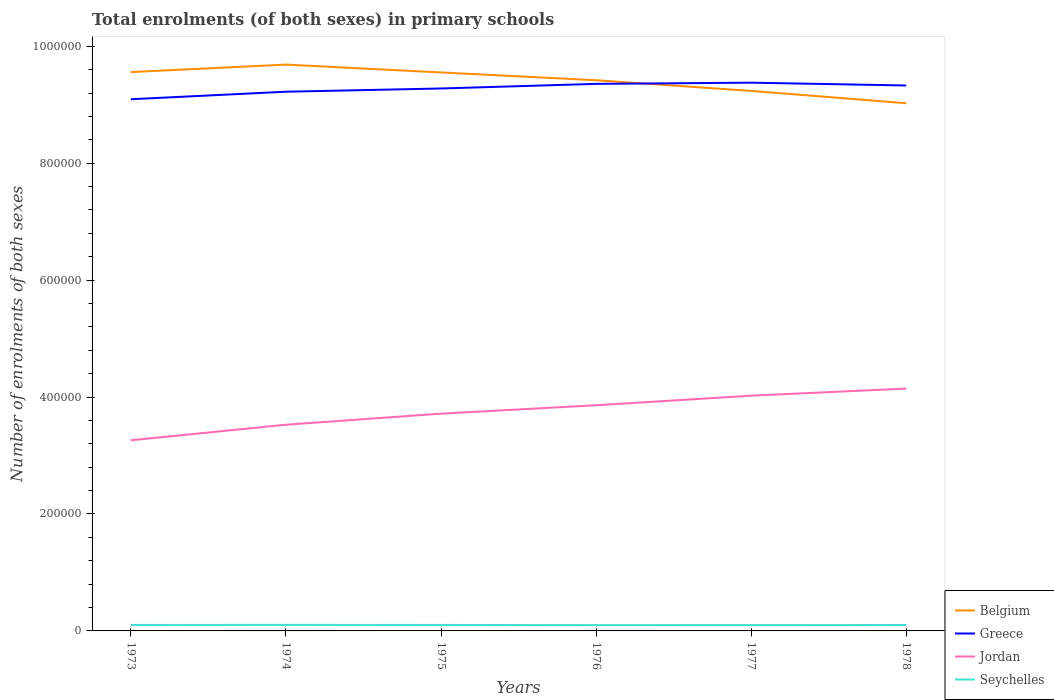Is the number of lines equal to the number of legend labels?
Give a very brief answer. Yes. Across all years, what is the maximum number of enrolments in primary schools in Belgium?
Provide a succinct answer. 9.03e+05. In which year was the number of enrolments in primary schools in Belgium maximum?
Make the answer very short. 1978. What is the total number of enrolments in primary schools in Belgium in the graph?
Your answer should be compact. 2.67e+04. What is the difference between the highest and the second highest number of enrolments in primary schools in Jordan?
Give a very brief answer. 8.84e+04. How many lines are there?
Give a very brief answer. 4. How many years are there in the graph?
Offer a terse response. 6. Are the values on the major ticks of Y-axis written in scientific E-notation?
Your response must be concise. No. Where does the legend appear in the graph?
Your response must be concise. Bottom right. How many legend labels are there?
Give a very brief answer. 4. How are the legend labels stacked?
Offer a terse response. Vertical. What is the title of the graph?
Offer a very short reply. Total enrolments (of both sexes) in primary schools. Does "Congo (Democratic)" appear as one of the legend labels in the graph?
Offer a terse response. No. What is the label or title of the X-axis?
Provide a short and direct response. Years. What is the label or title of the Y-axis?
Your answer should be compact. Number of enrolments of both sexes. What is the Number of enrolments of both sexes of Belgium in 1973?
Give a very brief answer. 9.56e+05. What is the Number of enrolments of both sexes of Greece in 1973?
Provide a short and direct response. 9.09e+05. What is the Number of enrolments of both sexes in Jordan in 1973?
Offer a terse response. 3.26e+05. What is the Number of enrolments of both sexes of Seychelles in 1973?
Provide a short and direct response. 1.03e+04. What is the Number of enrolments of both sexes of Belgium in 1974?
Offer a very short reply. 9.69e+05. What is the Number of enrolments of both sexes of Greece in 1974?
Give a very brief answer. 9.22e+05. What is the Number of enrolments of both sexes in Jordan in 1974?
Make the answer very short. 3.53e+05. What is the Number of enrolments of both sexes of Seychelles in 1974?
Your response must be concise. 1.04e+04. What is the Number of enrolments of both sexes in Belgium in 1975?
Your answer should be compact. 9.55e+05. What is the Number of enrolments of both sexes of Greece in 1975?
Offer a very short reply. 9.28e+05. What is the Number of enrolments of both sexes of Jordan in 1975?
Your answer should be very brief. 3.72e+05. What is the Number of enrolments of both sexes of Seychelles in 1975?
Your answer should be very brief. 1.02e+04. What is the Number of enrolments of both sexes in Belgium in 1976?
Offer a very short reply. 9.42e+05. What is the Number of enrolments of both sexes of Greece in 1976?
Ensure brevity in your answer.  9.36e+05. What is the Number of enrolments of both sexes in Jordan in 1976?
Your response must be concise. 3.86e+05. What is the Number of enrolments of both sexes of Seychelles in 1976?
Offer a very short reply. 9950. What is the Number of enrolments of both sexes in Belgium in 1977?
Ensure brevity in your answer.  9.24e+05. What is the Number of enrolments of both sexes in Greece in 1977?
Keep it short and to the point. 9.38e+05. What is the Number of enrolments of both sexes in Jordan in 1977?
Offer a very short reply. 4.02e+05. What is the Number of enrolments of both sexes in Seychelles in 1977?
Your answer should be compact. 1.00e+04. What is the Number of enrolments of both sexes in Belgium in 1978?
Ensure brevity in your answer.  9.03e+05. What is the Number of enrolments of both sexes in Greece in 1978?
Your response must be concise. 9.33e+05. What is the Number of enrolments of both sexes of Jordan in 1978?
Ensure brevity in your answer.  4.14e+05. What is the Number of enrolments of both sexes of Seychelles in 1978?
Your answer should be very brief. 1.01e+04. Across all years, what is the maximum Number of enrolments of both sexes in Belgium?
Your answer should be compact. 9.69e+05. Across all years, what is the maximum Number of enrolments of both sexes of Greece?
Your answer should be very brief. 9.38e+05. Across all years, what is the maximum Number of enrolments of both sexes of Jordan?
Your answer should be compact. 4.14e+05. Across all years, what is the maximum Number of enrolments of both sexes in Seychelles?
Ensure brevity in your answer.  1.04e+04. Across all years, what is the minimum Number of enrolments of both sexes in Belgium?
Keep it short and to the point. 9.03e+05. Across all years, what is the minimum Number of enrolments of both sexes in Greece?
Your response must be concise. 9.09e+05. Across all years, what is the minimum Number of enrolments of both sexes in Jordan?
Your response must be concise. 3.26e+05. Across all years, what is the minimum Number of enrolments of both sexes of Seychelles?
Ensure brevity in your answer.  9950. What is the total Number of enrolments of both sexes in Belgium in the graph?
Provide a succinct answer. 5.65e+06. What is the total Number of enrolments of both sexes in Greece in the graph?
Provide a succinct answer. 5.57e+06. What is the total Number of enrolments of both sexes in Jordan in the graph?
Ensure brevity in your answer.  2.25e+06. What is the total Number of enrolments of both sexes in Seychelles in the graph?
Offer a very short reply. 6.09e+04. What is the difference between the Number of enrolments of both sexes in Belgium in 1973 and that in 1974?
Keep it short and to the point. -1.28e+04. What is the difference between the Number of enrolments of both sexes of Greece in 1973 and that in 1974?
Your answer should be compact. -1.29e+04. What is the difference between the Number of enrolments of both sexes in Jordan in 1973 and that in 1974?
Give a very brief answer. -2.66e+04. What is the difference between the Number of enrolments of both sexes in Seychelles in 1973 and that in 1974?
Give a very brief answer. -80. What is the difference between the Number of enrolments of both sexes in Belgium in 1973 and that in 1975?
Ensure brevity in your answer.  665. What is the difference between the Number of enrolments of both sexes in Greece in 1973 and that in 1975?
Ensure brevity in your answer.  -1.84e+04. What is the difference between the Number of enrolments of both sexes in Jordan in 1973 and that in 1975?
Your answer should be compact. -4.55e+04. What is the difference between the Number of enrolments of both sexes in Belgium in 1973 and that in 1976?
Offer a terse response. 1.40e+04. What is the difference between the Number of enrolments of both sexes of Greece in 1973 and that in 1976?
Keep it short and to the point. -2.63e+04. What is the difference between the Number of enrolments of both sexes in Jordan in 1973 and that in 1976?
Give a very brief answer. -5.99e+04. What is the difference between the Number of enrolments of both sexes in Seychelles in 1973 and that in 1976?
Keep it short and to the point. 325. What is the difference between the Number of enrolments of both sexes in Belgium in 1973 and that in 1977?
Make the answer very short. 3.22e+04. What is the difference between the Number of enrolments of both sexes of Greece in 1973 and that in 1977?
Your answer should be very brief. -2.83e+04. What is the difference between the Number of enrolments of both sexes in Jordan in 1973 and that in 1977?
Your answer should be compact. -7.63e+04. What is the difference between the Number of enrolments of both sexes in Seychelles in 1973 and that in 1977?
Keep it short and to the point. 274. What is the difference between the Number of enrolments of both sexes of Belgium in 1973 and that in 1978?
Provide a succinct answer. 5.33e+04. What is the difference between the Number of enrolments of both sexes in Greece in 1973 and that in 1978?
Your response must be concise. -2.35e+04. What is the difference between the Number of enrolments of both sexes of Jordan in 1973 and that in 1978?
Keep it short and to the point. -8.84e+04. What is the difference between the Number of enrolments of both sexes in Seychelles in 1973 and that in 1978?
Provide a short and direct response. 152. What is the difference between the Number of enrolments of both sexes in Belgium in 1974 and that in 1975?
Provide a succinct answer. 1.34e+04. What is the difference between the Number of enrolments of both sexes of Greece in 1974 and that in 1975?
Provide a succinct answer. -5550. What is the difference between the Number of enrolments of both sexes in Jordan in 1974 and that in 1975?
Your answer should be very brief. -1.89e+04. What is the difference between the Number of enrolments of both sexes of Seychelles in 1974 and that in 1975?
Offer a very short reply. 123. What is the difference between the Number of enrolments of both sexes in Belgium in 1974 and that in 1976?
Give a very brief answer. 2.67e+04. What is the difference between the Number of enrolments of both sexes in Greece in 1974 and that in 1976?
Provide a succinct answer. -1.34e+04. What is the difference between the Number of enrolments of both sexes of Jordan in 1974 and that in 1976?
Ensure brevity in your answer.  -3.33e+04. What is the difference between the Number of enrolments of both sexes in Seychelles in 1974 and that in 1976?
Your answer should be compact. 405. What is the difference between the Number of enrolments of both sexes in Belgium in 1974 and that in 1977?
Offer a very short reply. 4.50e+04. What is the difference between the Number of enrolments of both sexes in Greece in 1974 and that in 1977?
Offer a very short reply. -1.55e+04. What is the difference between the Number of enrolments of both sexes in Jordan in 1974 and that in 1977?
Your answer should be compact. -4.97e+04. What is the difference between the Number of enrolments of both sexes in Seychelles in 1974 and that in 1977?
Provide a succinct answer. 354. What is the difference between the Number of enrolments of both sexes in Belgium in 1974 and that in 1978?
Provide a succinct answer. 6.61e+04. What is the difference between the Number of enrolments of both sexes in Greece in 1974 and that in 1978?
Keep it short and to the point. -1.07e+04. What is the difference between the Number of enrolments of both sexes in Jordan in 1974 and that in 1978?
Your answer should be very brief. -6.18e+04. What is the difference between the Number of enrolments of both sexes of Seychelles in 1974 and that in 1978?
Your response must be concise. 232. What is the difference between the Number of enrolments of both sexes in Belgium in 1975 and that in 1976?
Your answer should be very brief. 1.33e+04. What is the difference between the Number of enrolments of both sexes of Greece in 1975 and that in 1976?
Keep it short and to the point. -7882. What is the difference between the Number of enrolments of both sexes in Jordan in 1975 and that in 1976?
Your response must be concise. -1.44e+04. What is the difference between the Number of enrolments of both sexes of Seychelles in 1975 and that in 1976?
Offer a very short reply. 282. What is the difference between the Number of enrolments of both sexes in Belgium in 1975 and that in 1977?
Provide a short and direct response. 3.16e+04. What is the difference between the Number of enrolments of both sexes in Greece in 1975 and that in 1977?
Offer a terse response. -9932. What is the difference between the Number of enrolments of both sexes in Jordan in 1975 and that in 1977?
Give a very brief answer. -3.08e+04. What is the difference between the Number of enrolments of both sexes in Seychelles in 1975 and that in 1977?
Offer a very short reply. 231. What is the difference between the Number of enrolments of both sexes in Belgium in 1975 and that in 1978?
Your answer should be compact. 5.26e+04. What is the difference between the Number of enrolments of both sexes of Greece in 1975 and that in 1978?
Provide a succinct answer. -5130. What is the difference between the Number of enrolments of both sexes in Jordan in 1975 and that in 1978?
Your answer should be very brief. -4.29e+04. What is the difference between the Number of enrolments of both sexes in Seychelles in 1975 and that in 1978?
Offer a very short reply. 109. What is the difference between the Number of enrolments of both sexes of Belgium in 1976 and that in 1977?
Your response must be concise. 1.83e+04. What is the difference between the Number of enrolments of both sexes of Greece in 1976 and that in 1977?
Your answer should be very brief. -2050. What is the difference between the Number of enrolments of both sexes in Jordan in 1976 and that in 1977?
Make the answer very short. -1.64e+04. What is the difference between the Number of enrolments of both sexes in Seychelles in 1976 and that in 1977?
Ensure brevity in your answer.  -51. What is the difference between the Number of enrolments of both sexes of Belgium in 1976 and that in 1978?
Ensure brevity in your answer.  3.93e+04. What is the difference between the Number of enrolments of both sexes of Greece in 1976 and that in 1978?
Keep it short and to the point. 2752. What is the difference between the Number of enrolments of both sexes of Jordan in 1976 and that in 1978?
Give a very brief answer. -2.85e+04. What is the difference between the Number of enrolments of both sexes of Seychelles in 1976 and that in 1978?
Offer a terse response. -173. What is the difference between the Number of enrolments of both sexes of Belgium in 1977 and that in 1978?
Provide a short and direct response. 2.10e+04. What is the difference between the Number of enrolments of both sexes of Greece in 1977 and that in 1978?
Make the answer very short. 4802. What is the difference between the Number of enrolments of both sexes in Jordan in 1977 and that in 1978?
Offer a terse response. -1.21e+04. What is the difference between the Number of enrolments of both sexes in Seychelles in 1977 and that in 1978?
Ensure brevity in your answer.  -122. What is the difference between the Number of enrolments of both sexes in Belgium in 1973 and the Number of enrolments of both sexes in Greece in 1974?
Your answer should be compact. 3.36e+04. What is the difference between the Number of enrolments of both sexes of Belgium in 1973 and the Number of enrolments of both sexes of Jordan in 1974?
Keep it short and to the point. 6.03e+05. What is the difference between the Number of enrolments of both sexes of Belgium in 1973 and the Number of enrolments of both sexes of Seychelles in 1974?
Your answer should be compact. 9.46e+05. What is the difference between the Number of enrolments of both sexes of Greece in 1973 and the Number of enrolments of both sexes of Jordan in 1974?
Your answer should be very brief. 5.57e+05. What is the difference between the Number of enrolments of both sexes of Greece in 1973 and the Number of enrolments of both sexes of Seychelles in 1974?
Ensure brevity in your answer.  8.99e+05. What is the difference between the Number of enrolments of both sexes of Jordan in 1973 and the Number of enrolments of both sexes of Seychelles in 1974?
Keep it short and to the point. 3.16e+05. What is the difference between the Number of enrolments of both sexes in Belgium in 1973 and the Number of enrolments of both sexes in Greece in 1975?
Give a very brief answer. 2.81e+04. What is the difference between the Number of enrolments of both sexes of Belgium in 1973 and the Number of enrolments of both sexes of Jordan in 1975?
Provide a succinct answer. 5.84e+05. What is the difference between the Number of enrolments of both sexes in Belgium in 1973 and the Number of enrolments of both sexes in Seychelles in 1975?
Offer a very short reply. 9.46e+05. What is the difference between the Number of enrolments of both sexes in Greece in 1973 and the Number of enrolments of both sexes in Jordan in 1975?
Make the answer very short. 5.38e+05. What is the difference between the Number of enrolments of both sexes of Greece in 1973 and the Number of enrolments of both sexes of Seychelles in 1975?
Provide a short and direct response. 8.99e+05. What is the difference between the Number of enrolments of both sexes in Jordan in 1973 and the Number of enrolments of both sexes in Seychelles in 1975?
Your answer should be compact. 3.16e+05. What is the difference between the Number of enrolments of both sexes in Belgium in 1973 and the Number of enrolments of both sexes in Greece in 1976?
Your answer should be compact. 2.02e+04. What is the difference between the Number of enrolments of both sexes in Belgium in 1973 and the Number of enrolments of both sexes in Jordan in 1976?
Make the answer very short. 5.70e+05. What is the difference between the Number of enrolments of both sexes of Belgium in 1973 and the Number of enrolments of both sexes of Seychelles in 1976?
Offer a terse response. 9.46e+05. What is the difference between the Number of enrolments of both sexes of Greece in 1973 and the Number of enrolments of both sexes of Jordan in 1976?
Give a very brief answer. 5.23e+05. What is the difference between the Number of enrolments of both sexes of Greece in 1973 and the Number of enrolments of both sexes of Seychelles in 1976?
Your answer should be compact. 8.99e+05. What is the difference between the Number of enrolments of both sexes of Jordan in 1973 and the Number of enrolments of both sexes of Seychelles in 1976?
Provide a short and direct response. 3.16e+05. What is the difference between the Number of enrolments of both sexes in Belgium in 1973 and the Number of enrolments of both sexes in Greece in 1977?
Offer a very short reply. 1.81e+04. What is the difference between the Number of enrolments of both sexes in Belgium in 1973 and the Number of enrolments of both sexes in Jordan in 1977?
Offer a terse response. 5.54e+05. What is the difference between the Number of enrolments of both sexes in Belgium in 1973 and the Number of enrolments of both sexes in Seychelles in 1977?
Your answer should be very brief. 9.46e+05. What is the difference between the Number of enrolments of both sexes in Greece in 1973 and the Number of enrolments of both sexes in Jordan in 1977?
Give a very brief answer. 5.07e+05. What is the difference between the Number of enrolments of both sexes in Greece in 1973 and the Number of enrolments of both sexes in Seychelles in 1977?
Offer a terse response. 8.99e+05. What is the difference between the Number of enrolments of both sexes in Jordan in 1973 and the Number of enrolments of both sexes in Seychelles in 1977?
Your answer should be compact. 3.16e+05. What is the difference between the Number of enrolments of both sexes in Belgium in 1973 and the Number of enrolments of both sexes in Greece in 1978?
Your response must be concise. 2.29e+04. What is the difference between the Number of enrolments of both sexes in Belgium in 1973 and the Number of enrolments of both sexes in Jordan in 1978?
Ensure brevity in your answer.  5.41e+05. What is the difference between the Number of enrolments of both sexes in Belgium in 1973 and the Number of enrolments of both sexes in Seychelles in 1978?
Provide a succinct answer. 9.46e+05. What is the difference between the Number of enrolments of both sexes in Greece in 1973 and the Number of enrolments of both sexes in Jordan in 1978?
Offer a very short reply. 4.95e+05. What is the difference between the Number of enrolments of both sexes of Greece in 1973 and the Number of enrolments of both sexes of Seychelles in 1978?
Provide a short and direct response. 8.99e+05. What is the difference between the Number of enrolments of both sexes of Jordan in 1973 and the Number of enrolments of both sexes of Seychelles in 1978?
Offer a terse response. 3.16e+05. What is the difference between the Number of enrolments of both sexes of Belgium in 1974 and the Number of enrolments of both sexes of Greece in 1975?
Make the answer very short. 4.08e+04. What is the difference between the Number of enrolments of both sexes of Belgium in 1974 and the Number of enrolments of both sexes of Jordan in 1975?
Provide a succinct answer. 5.97e+05. What is the difference between the Number of enrolments of both sexes of Belgium in 1974 and the Number of enrolments of both sexes of Seychelles in 1975?
Your response must be concise. 9.58e+05. What is the difference between the Number of enrolments of both sexes of Greece in 1974 and the Number of enrolments of both sexes of Jordan in 1975?
Provide a short and direct response. 5.51e+05. What is the difference between the Number of enrolments of both sexes in Greece in 1974 and the Number of enrolments of both sexes in Seychelles in 1975?
Provide a short and direct response. 9.12e+05. What is the difference between the Number of enrolments of both sexes in Jordan in 1974 and the Number of enrolments of both sexes in Seychelles in 1975?
Keep it short and to the point. 3.42e+05. What is the difference between the Number of enrolments of both sexes of Belgium in 1974 and the Number of enrolments of both sexes of Greece in 1976?
Offer a terse response. 3.30e+04. What is the difference between the Number of enrolments of both sexes in Belgium in 1974 and the Number of enrolments of both sexes in Jordan in 1976?
Your answer should be very brief. 5.83e+05. What is the difference between the Number of enrolments of both sexes in Belgium in 1974 and the Number of enrolments of both sexes in Seychelles in 1976?
Provide a short and direct response. 9.59e+05. What is the difference between the Number of enrolments of both sexes of Greece in 1974 and the Number of enrolments of both sexes of Jordan in 1976?
Your response must be concise. 5.36e+05. What is the difference between the Number of enrolments of both sexes in Greece in 1974 and the Number of enrolments of both sexes in Seychelles in 1976?
Ensure brevity in your answer.  9.12e+05. What is the difference between the Number of enrolments of both sexes of Jordan in 1974 and the Number of enrolments of both sexes of Seychelles in 1976?
Give a very brief answer. 3.43e+05. What is the difference between the Number of enrolments of both sexes in Belgium in 1974 and the Number of enrolments of both sexes in Greece in 1977?
Your answer should be compact. 3.09e+04. What is the difference between the Number of enrolments of both sexes in Belgium in 1974 and the Number of enrolments of both sexes in Jordan in 1977?
Give a very brief answer. 5.66e+05. What is the difference between the Number of enrolments of both sexes in Belgium in 1974 and the Number of enrolments of both sexes in Seychelles in 1977?
Your answer should be compact. 9.59e+05. What is the difference between the Number of enrolments of both sexes of Greece in 1974 and the Number of enrolments of both sexes of Jordan in 1977?
Give a very brief answer. 5.20e+05. What is the difference between the Number of enrolments of both sexes of Greece in 1974 and the Number of enrolments of both sexes of Seychelles in 1977?
Ensure brevity in your answer.  9.12e+05. What is the difference between the Number of enrolments of both sexes in Jordan in 1974 and the Number of enrolments of both sexes in Seychelles in 1977?
Give a very brief answer. 3.43e+05. What is the difference between the Number of enrolments of both sexes in Belgium in 1974 and the Number of enrolments of both sexes in Greece in 1978?
Your response must be concise. 3.57e+04. What is the difference between the Number of enrolments of both sexes of Belgium in 1974 and the Number of enrolments of both sexes of Jordan in 1978?
Make the answer very short. 5.54e+05. What is the difference between the Number of enrolments of both sexes in Belgium in 1974 and the Number of enrolments of both sexes in Seychelles in 1978?
Your answer should be compact. 9.59e+05. What is the difference between the Number of enrolments of both sexes in Greece in 1974 and the Number of enrolments of both sexes in Jordan in 1978?
Your answer should be compact. 5.08e+05. What is the difference between the Number of enrolments of both sexes in Greece in 1974 and the Number of enrolments of both sexes in Seychelles in 1978?
Offer a terse response. 9.12e+05. What is the difference between the Number of enrolments of both sexes of Jordan in 1974 and the Number of enrolments of both sexes of Seychelles in 1978?
Your answer should be very brief. 3.43e+05. What is the difference between the Number of enrolments of both sexes of Belgium in 1975 and the Number of enrolments of both sexes of Greece in 1976?
Ensure brevity in your answer.  1.95e+04. What is the difference between the Number of enrolments of both sexes of Belgium in 1975 and the Number of enrolments of both sexes of Jordan in 1976?
Ensure brevity in your answer.  5.69e+05. What is the difference between the Number of enrolments of both sexes of Belgium in 1975 and the Number of enrolments of both sexes of Seychelles in 1976?
Provide a short and direct response. 9.45e+05. What is the difference between the Number of enrolments of both sexes in Greece in 1975 and the Number of enrolments of both sexes in Jordan in 1976?
Ensure brevity in your answer.  5.42e+05. What is the difference between the Number of enrolments of both sexes of Greece in 1975 and the Number of enrolments of both sexes of Seychelles in 1976?
Your response must be concise. 9.18e+05. What is the difference between the Number of enrolments of both sexes in Jordan in 1975 and the Number of enrolments of both sexes in Seychelles in 1976?
Your response must be concise. 3.62e+05. What is the difference between the Number of enrolments of both sexes in Belgium in 1975 and the Number of enrolments of both sexes in Greece in 1977?
Provide a succinct answer. 1.75e+04. What is the difference between the Number of enrolments of both sexes in Belgium in 1975 and the Number of enrolments of both sexes in Jordan in 1977?
Keep it short and to the point. 5.53e+05. What is the difference between the Number of enrolments of both sexes of Belgium in 1975 and the Number of enrolments of both sexes of Seychelles in 1977?
Make the answer very short. 9.45e+05. What is the difference between the Number of enrolments of both sexes in Greece in 1975 and the Number of enrolments of both sexes in Jordan in 1977?
Your answer should be very brief. 5.25e+05. What is the difference between the Number of enrolments of both sexes of Greece in 1975 and the Number of enrolments of both sexes of Seychelles in 1977?
Ensure brevity in your answer.  9.18e+05. What is the difference between the Number of enrolments of both sexes in Jordan in 1975 and the Number of enrolments of both sexes in Seychelles in 1977?
Ensure brevity in your answer.  3.62e+05. What is the difference between the Number of enrolments of both sexes of Belgium in 1975 and the Number of enrolments of both sexes of Greece in 1978?
Your response must be concise. 2.23e+04. What is the difference between the Number of enrolments of both sexes of Belgium in 1975 and the Number of enrolments of both sexes of Jordan in 1978?
Offer a very short reply. 5.41e+05. What is the difference between the Number of enrolments of both sexes of Belgium in 1975 and the Number of enrolments of both sexes of Seychelles in 1978?
Your answer should be compact. 9.45e+05. What is the difference between the Number of enrolments of both sexes in Greece in 1975 and the Number of enrolments of both sexes in Jordan in 1978?
Keep it short and to the point. 5.13e+05. What is the difference between the Number of enrolments of both sexes in Greece in 1975 and the Number of enrolments of both sexes in Seychelles in 1978?
Keep it short and to the point. 9.18e+05. What is the difference between the Number of enrolments of both sexes in Jordan in 1975 and the Number of enrolments of both sexes in Seychelles in 1978?
Your answer should be compact. 3.62e+05. What is the difference between the Number of enrolments of both sexes in Belgium in 1976 and the Number of enrolments of both sexes in Greece in 1977?
Give a very brief answer. 4161. What is the difference between the Number of enrolments of both sexes in Belgium in 1976 and the Number of enrolments of both sexes in Jordan in 1977?
Offer a very short reply. 5.40e+05. What is the difference between the Number of enrolments of both sexes in Belgium in 1976 and the Number of enrolments of both sexes in Seychelles in 1977?
Provide a succinct answer. 9.32e+05. What is the difference between the Number of enrolments of both sexes of Greece in 1976 and the Number of enrolments of both sexes of Jordan in 1977?
Ensure brevity in your answer.  5.33e+05. What is the difference between the Number of enrolments of both sexes in Greece in 1976 and the Number of enrolments of both sexes in Seychelles in 1977?
Your answer should be very brief. 9.26e+05. What is the difference between the Number of enrolments of both sexes in Jordan in 1976 and the Number of enrolments of both sexes in Seychelles in 1977?
Ensure brevity in your answer.  3.76e+05. What is the difference between the Number of enrolments of both sexes in Belgium in 1976 and the Number of enrolments of both sexes in Greece in 1978?
Provide a short and direct response. 8963. What is the difference between the Number of enrolments of both sexes of Belgium in 1976 and the Number of enrolments of both sexes of Jordan in 1978?
Give a very brief answer. 5.27e+05. What is the difference between the Number of enrolments of both sexes in Belgium in 1976 and the Number of enrolments of both sexes in Seychelles in 1978?
Provide a short and direct response. 9.32e+05. What is the difference between the Number of enrolments of both sexes in Greece in 1976 and the Number of enrolments of both sexes in Jordan in 1978?
Provide a short and direct response. 5.21e+05. What is the difference between the Number of enrolments of both sexes of Greece in 1976 and the Number of enrolments of both sexes of Seychelles in 1978?
Your answer should be compact. 9.26e+05. What is the difference between the Number of enrolments of both sexes of Jordan in 1976 and the Number of enrolments of both sexes of Seychelles in 1978?
Your answer should be very brief. 3.76e+05. What is the difference between the Number of enrolments of both sexes of Belgium in 1977 and the Number of enrolments of both sexes of Greece in 1978?
Your answer should be very brief. -9301. What is the difference between the Number of enrolments of both sexes in Belgium in 1977 and the Number of enrolments of both sexes in Jordan in 1978?
Make the answer very short. 5.09e+05. What is the difference between the Number of enrolments of both sexes of Belgium in 1977 and the Number of enrolments of both sexes of Seychelles in 1978?
Offer a terse response. 9.14e+05. What is the difference between the Number of enrolments of both sexes in Greece in 1977 and the Number of enrolments of both sexes in Jordan in 1978?
Your answer should be very brief. 5.23e+05. What is the difference between the Number of enrolments of both sexes in Greece in 1977 and the Number of enrolments of both sexes in Seychelles in 1978?
Offer a very short reply. 9.28e+05. What is the difference between the Number of enrolments of both sexes of Jordan in 1977 and the Number of enrolments of both sexes of Seychelles in 1978?
Your response must be concise. 3.92e+05. What is the average Number of enrolments of both sexes in Belgium per year?
Provide a short and direct response. 9.41e+05. What is the average Number of enrolments of both sexes of Greece per year?
Keep it short and to the point. 9.28e+05. What is the average Number of enrolments of both sexes of Jordan per year?
Offer a terse response. 3.76e+05. What is the average Number of enrolments of both sexes in Seychelles per year?
Provide a succinct answer. 1.02e+04. In the year 1973, what is the difference between the Number of enrolments of both sexes in Belgium and Number of enrolments of both sexes in Greece?
Offer a terse response. 4.65e+04. In the year 1973, what is the difference between the Number of enrolments of both sexes in Belgium and Number of enrolments of both sexes in Jordan?
Provide a succinct answer. 6.30e+05. In the year 1973, what is the difference between the Number of enrolments of both sexes of Belgium and Number of enrolments of both sexes of Seychelles?
Your answer should be compact. 9.46e+05. In the year 1973, what is the difference between the Number of enrolments of both sexes of Greece and Number of enrolments of both sexes of Jordan?
Offer a very short reply. 5.83e+05. In the year 1973, what is the difference between the Number of enrolments of both sexes in Greece and Number of enrolments of both sexes in Seychelles?
Keep it short and to the point. 8.99e+05. In the year 1973, what is the difference between the Number of enrolments of both sexes of Jordan and Number of enrolments of both sexes of Seychelles?
Make the answer very short. 3.16e+05. In the year 1974, what is the difference between the Number of enrolments of both sexes in Belgium and Number of enrolments of both sexes in Greece?
Provide a short and direct response. 4.64e+04. In the year 1974, what is the difference between the Number of enrolments of both sexes of Belgium and Number of enrolments of both sexes of Jordan?
Your answer should be compact. 6.16e+05. In the year 1974, what is the difference between the Number of enrolments of both sexes in Belgium and Number of enrolments of both sexes in Seychelles?
Your response must be concise. 9.58e+05. In the year 1974, what is the difference between the Number of enrolments of both sexes in Greece and Number of enrolments of both sexes in Jordan?
Your response must be concise. 5.70e+05. In the year 1974, what is the difference between the Number of enrolments of both sexes in Greece and Number of enrolments of both sexes in Seychelles?
Give a very brief answer. 9.12e+05. In the year 1974, what is the difference between the Number of enrolments of both sexes of Jordan and Number of enrolments of both sexes of Seychelles?
Your answer should be very brief. 3.42e+05. In the year 1975, what is the difference between the Number of enrolments of both sexes of Belgium and Number of enrolments of both sexes of Greece?
Keep it short and to the point. 2.74e+04. In the year 1975, what is the difference between the Number of enrolments of both sexes of Belgium and Number of enrolments of both sexes of Jordan?
Your response must be concise. 5.84e+05. In the year 1975, what is the difference between the Number of enrolments of both sexes in Belgium and Number of enrolments of both sexes in Seychelles?
Your response must be concise. 9.45e+05. In the year 1975, what is the difference between the Number of enrolments of both sexes of Greece and Number of enrolments of both sexes of Jordan?
Keep it short and to the point. 5.56e+05. In the year 1975, what is the difference between the Number of enrolments of both sexes in Greece and Number of enrolments of both sexes in Seychelles?
Keep it short and to the point. 9.18e+05. In the year 1975, what is the difference between the Number of enrolments of both sexes in Jordan and Number of enrolments of both sexes in Seychelles?
Ensure brevity in your answer.  3.61e+05. In the year 1976, what is the difference between the Number of enrolments of both sexes of Belgium and Number of enrolments of both sexes of Greece?
Your response must be concise. 6211. In the year 1976, what is the difference between the Number of enrolments of both sexes of Belgium and Number of enrolments of both sexes of Jordan?
Your answer should be compact. 5.56e+05. In the year 1976, what is the difference between the Number of enrolments of both sexes of Belgium and Number of enrolments of both sexes of Seychelles?
Offer a terse response. 9.32e+05. In the year 1976, what is the difference between the Number of enrolments of both sexes in Greece and Number of enrolments of both sexes in Jordan?
Provide a succinct answer. 5.50e+05. In the year 1976, what is the difference between the Number of enrolments of both sexes of Greece and Number of enrolments of both sexes of Seychelles?
Your response must be concise. 9.26e+05. In the year 1976, what is the difference between the Number of enrolments of both sexes of Jordan and Number of enrolments of both sexes of Seychelles?
Your answer should be compact. 3.76e+05. In the year 1977, what is the difference between the Number of enrolments of both sexes in Belgium and Number of enrolments of both sexes in Greece?
Your answer should be compact. -1.41e+04. In the year 1977, what is the difference between the Number of enrolments of both sexes of Belgium and Number of enrolments of both sexes of Jordan?
Keep it short and to the point. 5.21e+05. In the year 1977, what is the difference between the Number of enrolments of both sexes in Belgium and Number of enrolments of both sexes in Seychelles?
Your answer should be compact. 9.14e+05. In the year 1977, what is the difference between the Number of enrolments of both sexes of Greece and Number of enrolments of both sexes of Jordan?
Give a very brief answer. 5.35e+05. In the year 1977, what is the difference between the Number of enrolments of both sexes of Greece and Number of enrolments of both sexes of Seychelles?
Your response must be concise. 9.28e+05. In the year 1977, what is the difference between the Number of enrolments of both sexes in Jordan and Number of enrolments of both sexes in Seychelles?
Your answer should be very brief. 3.92e+05. In the year 1978, what is the difference between the Number of enrolments of both sexes of Belgium and Number of enrolments of both sexes of Greece?
Offer a terse response. -3.04e+04. In the year 1978, what is the difference between the Number of enrolments of both sexes of Belgium and Number of enrolments of both sexes of Jordan?
Your answer should be compact. 4.88e+05. In the year 1978, what is the difference between the Number of enrolments of both sexes of Belgium and Number of enrolments of both sexes of Seychelles?
Your answer should be compact. 8.93e+05. In the year 1978, what is the difference between the Number of enrolments of both sexes of Greece and Number of enrolments of both sexes of Jordan?
Ensure brevity in your answer.  5.18e+05. In the year 1978, what is the difference between the Number of enrolments of both sexes in Greece and Number of enrolments of both sexes in Seychelles?
Your response must be concise. 9.23e+05. In the year 1978, what is the difference between the Number of enrolments of both sexes in Jordan and Number of enrolments of both sexes in Seychelles?
Give a very brief answer. 4.04e+05. What is the ratio of the Number of enrolments of both sexes in Greece in 1973 to that in 1974?
Your response must be concise. 0.99. What is the ratio of the Number of enrolments of both sexes in Jordan in 1973 to that in 1974?
Your answer should be compact. 0.92. What is the ratio of the Number of enrolments of both sexes of Greece in 1973 to that in 1975?
Your response must be concise. 0.98. What is the ratio of the Number of enrolments of both sexes in Jordan in 1973 to that in 1975?
Your answer should be very brief. 0.88. What is the ratio of the Number of enrolments of both sexes of Belgium in 1973 to that in 1976?
Your response must be concise. 1.01. What is the ratio of the Number of enrolments of both sexes of Greece in 1973 to that in 1976?
Your response must be concise. 0.97. What is the ratio of the Number of enrolments of both sexes of Jordan in 1973 to that in 1976?
Your response must be concise. 0.84. What is the ratio of the Number of enrolments of both sexes of Seychelles in 1973 to that in 1976?
Provide a succinct answer. 1.03. What is the ratio of the Number of enrolments of both sexes of Belgium in 1973 to that in 1977?
Provide a short and direct response. 1.03. What is the ratio of the Number of enrolments of both sexes in Greece in 1973 to that in 1977?
Your response must be concise. 0.97. What is the ratio of the Number of enrolments of both sexes in Jordan in 1973 to that in 1977?
Your answer should be very brief. 0.81. What is the ratio of the Number of enrolments of both sexes in Seychelles in 1973 to that in 1977?
Offer a terse response. 1.03. What is the ratio of the Number of enrolments of both sexes in Belgium in 1973 to that in 1978?
Offer a terse response. 1.06. What is the ratio of the Number of enrolments of both sexes of Greece in 1973 to that in 1978?
Your answer should be very brief. 0.97. What is the ratio of the Number of enrolments of both sexes in Jordan in 1973 to that in 1978?
Ensure brevity in your answer.  0.79. What is the ratio of the Number of enrolments of both sexes in Belgium in 1974 to that in 1975?
Keep it short and to the point. 1.01. What is the ratio of the Number of enrolments of both sexes in Jordan in 1974 to that in 1975?
Your answer should be very brief. 0.95. What is the ratio of the Number of enrolments of both sexes of Seychelles in 1974 to that in 1975?
Offer a very short reply. 1.01. What is the ratio of the Number of enrolments of both sexes of Belgium in 1974 to that in 1976?
Your response must be concise. 1.03. What is the ratio of the Number of enrolments of both sexes in Greece in 1974 to that in 1976?
Provide a succinct answer. 0.99. What is the ratio of the Number of enrolments of both sexes in Jordan in 1974 to that in 1976?
Your answer should be very brief. 0.91. What is the ratio of the Number of enrolments of both sexes in Seychelles in 1974 to that in 1976?
Provide a succinct answer. 1.04. What is the ratio of the Number of enrolments of both sexes in Belgium in 1974 to that in 1977?
Your response must be concise. 1.05. What is the ratio of the Number of enrolments of both sexes of Greece in 1974 to that in 1977?
Keep it short and to the point. 0.98. What is the ratio of the Number of enrolments of both sexes in Jordan in 1974 to that in 1977?
Give a very brief answer. 0.88. What is the ratio of the Number of enrolments of both sexes of Seychelles in 1974 to that in 1977?
Give a very brief answer. 1.04. What is the ratio of the Number of enrolments of both sexes in Belgium in 1974 to that in 1978?
Keep it short and to the point. 1.07. What is the ratio of the Number of enrolments of both sexes in Greece in 1974 to that in 1978?
Provide a succinct answer. 0.99. What is the ratio of the Number of enrolments of both sexes in Jordan in 1974 to that in 1978?
Keep it short and to the point. 0.85. What is the ratio of the Number of enrolments of both sexes in Seychelles in 1974 to that in 1978?
Make the answer very short. 1.02. What is the ratio of the Number of enrolments of both sexes of Belgium in 1975 to that in 1976?
Provide a succinct answer. 1.01. What is the ratio of the Number of enrolments of both sexes in Greece in 1975 to that in 1976?
Offer a terse response. 0.99. What is the ratio of the Number of enrolments of both sexes of Jordan in 1975 to that in 1976?
Your answer should be very brief. 0.96. What is the ratio of the Number of enrolments of both sexes of Seychelles in 1975 to that in 1976?
Offer a very short reply. 1.03. What is the ratio of the Number of enrolments of both sexes in Belgium in 1975 to that in 1977?
Your answer should be very brief. 1.03. What is the ratio of the Number of enrolments of both sexes in Greece in 1975 to that in 1977?
Provide a short and direct response. 0.99. What is the ratio of the Number of enrolments of both sexes in Jordan in 1975 to that in 1977?
Offer a terse response. 0.92. What is the ratio of the Number of enrolments of both sexes in Seychelles in 1975 to that in 1977?
Your answer should be very brief. 1.02. What is the ratio of the Number of enrolments of both sexes in Belgium in 1975 to that in 1978?
Your response must be concise. 1.06. What is the ratio of the Number of enrolments of both sexes of Greece in 1975 to that in 1978?
Your response must be concise. 0.99. What is the ratio of the Number of enrolments of both sexes of Jordan in 1975 to that in 1978?
Your answer should be compact. 0.9. What is the ratio of the Number of enrolments of both sexes of Seychelles in 1975 to that in 1978?
Offer a very short reply. 1.01. What is the ratio of the Number of enrolments of both sexes in Belgium in 1976 to that in 1977?
Keep it short and to the point. 1.02. What is the ratio of the Number of enrolments of both sexes of Greece in 1976 to that in 1977?
Provide a short and direct response. 1. What is the ratio of the Number of enrolments of both sexes in Jordan in 1976 to that in 1977?
Offer a terse response. 0.96. What is the ratio of the Number of enrolments of both sexes in Seychelles in 1976 to that in 1977?
Provide a succinct answer. 0.99. What is the ratio of the Number of enrolments of both sexes of Belgium in 1976 to that in 1978?
Ensure brevity in your answer.  1.04. What is the ratio of the Number of enrolments of both sexes in Greece in 1976 to that in 1978?
Give a very brief answer. 1. What is the ratio of the Number of enrolments of both sexes of Jordan in 1976 to that in 1978?
Provide a short and direct response. 0.93. What is the ratio of the Number of enrolments of both sexes in Seychelles in 1976 to that in 1978?
Provide a short and direct response. 0.98. What is the ratio of the Number of enrolments of both sexes in Belgium in 1977 to that in 1978?
Offer a very short reply. 1.02. What is the ratio of the Number of enrolments of both sexes in Greece in 1977 to that in 1978?
Your response must be concise. 1.01. What is the ratio of the Number of enrolments of both sexes in Jordan in 1977 to that in 1978?
Provide a short and direct response. 0.97. What is the ratio of the Number of enrolments of both sexes of Seychelles in 1977 to that in 1978?
Provide a succinct answer. 0.99. What is the difference between the highest and the second highest Number of enrolments of both sexes in Belgium?
Your response must be concise. 1.28e+04. What is the difference between the highest and the second highest Number of enrolments of both sexes in Greece?
Your answer should be very brief. 2050. What is the difference between the highest and the second highest Number of enrolments of both sexes of Jordan?
Your answer should be compact. 1.21e+04. What is the difference between the highest and the lowest Number of enrolments of both sexes in Belgium?
Your answer should be compact. 6.61e+04. What is the difference between the highest and the lowest Number of enrolments of both sexes in Greece?
Provide a short and direct response. 2.83e+04. What is the difference between the highest and the lowest Number of enrolments of both sexes of Jordan?
Your answer should be very brief. 8.84e+04. What is the difference between the highest and the lowest Number of enrolments of both sexes of Seychelles?
Offer a very short reply. 405. 